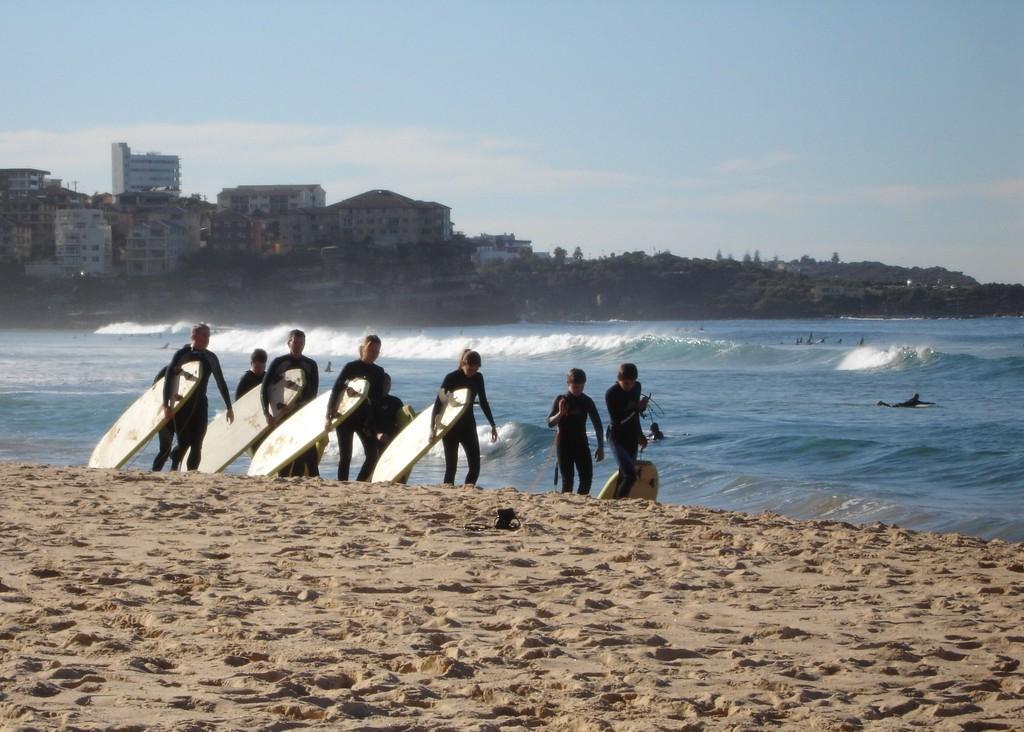In one or two sentences, can you explain what this image depicts? In this image i can see a person's catching the sky board and the back ground i can see few water floating, a tree , a building and a sky 